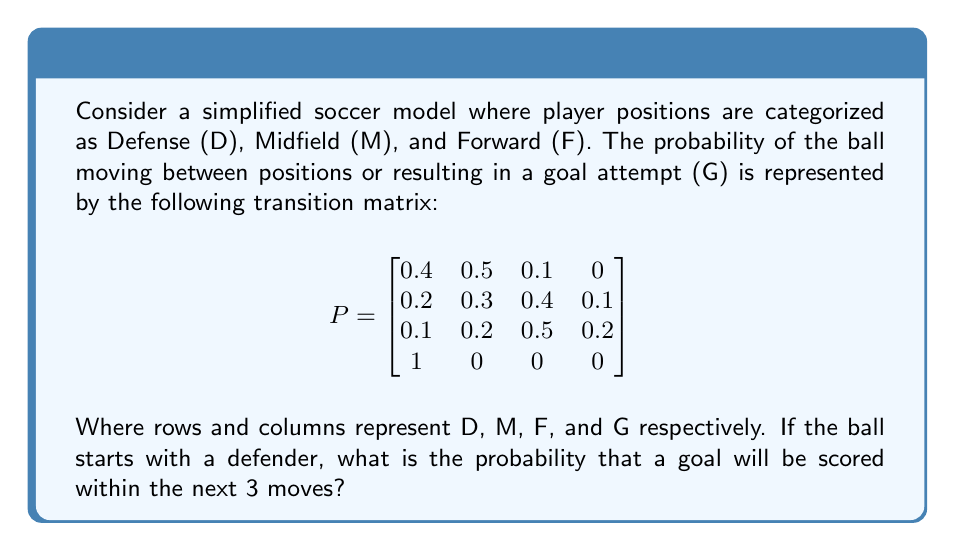What is the answer to this math problem? To solve this problem, we'll use the properties of Markov chains:

1) First, we need to calculate $P^2$ and $P^3$, as we're interested in the probability of scoring within 3 moves.

2) $P^2$ represents the probabilities after 2 moves:

$$
P^2 = \begin{bmatrix}
0.28 & 0.37 & 0.29 & 0.06 \\
0.26 & 0.34 & 0.31 & 0.09 \\
0.23 & 0.29 & 0.36 & 0.12 \\
0.4 & 0.5 & 0.1 & 0
\end{bmatrix}
$$

3) $P^3$ represents the probabilities after 3 moves:

$$
P^3 = \begin{bmatrix}
0.252 & 0.331 & 0.322 & 0.095 \\
0.246 & 0.323 & 0.328 & 0.103 \\
0.236 & 0.308 & 0.338 & 0.118 \\
0.28 & 0.37 & 0.29 & 0.06
\end{bmatrix}
$$

4) The probability of scoring within 3 moves when starting from defense is the sum of:
   - Probability of scoring in 1 move: $P_{DG} = 0$
   - Probability of scoring in 2 moves: $P^2_{DG} = 0.06$
   - Probability of scoring in 3 moves: $P^3_{DG} = 0.095$

5) Total probability = $0 + 0.06 + 0.095 = 0.155$
Answer: 0.155 